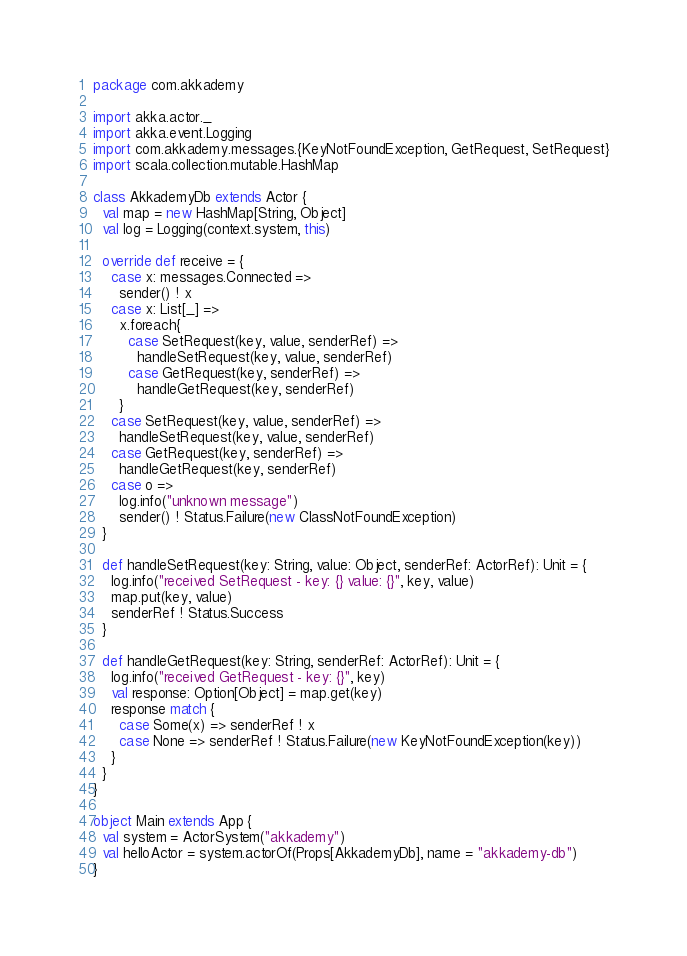<code> <loc_0><loc_0><loc_500><loc_500><_Scala_>package com.akkademy

import akka.actor._
import akka.event.Logging
import com.akkademy.messages.{KeyNotFoundException, GetRequest, SetRequest}
import scala.collection.mutable.HashMap

class AkkademyDb extends Actor {
  val map = new HashMap[String, Object]
  val log = Logging(context.system, this)

  override def receive = {
    case x: messages.Connected =>
      sender() ! x
    case x: List[_] =>
      x.foreach{
        case SetRequest(key, value, senderRef) =>
          handleSetRequest(key, value, senderRef)
        case GetRequest(key, senderRef) =>
          handleGetRequest(key, senderRef)
      }
    case SetRequest(key, value, senderRef) =>
      handleSetRequest(key, value, senderRef)
    case GetRequest(key, senderRef) =>
      handleGetRequest(key, senderRef)
    case o =>
      log.info("unknown message")
      sender() ! Status.Failure(new ClassNotFoundException)
  }

  def handleSetRequest(key: String, value: Object, senderRef: ActorRef): Unit = {
    log.info("received SetRequest - key: {} value: {}", key, value)
    map.put(key, value)
    senderRef ! Status.Success
  }

  def handleGetRequest(key: String, senderRef: ActorRef): Unit = {
    log.info("received GetRequest - key: {}", key)
    val response: Option[Object] = map.get(key)
    response match {
      case Some(x) => senderRef ! x
      case None => senderRef ! Status.Failure(new KeyNotFoundException(key))
    }
  }
}

object Main extends App {
  val system = ActorSystem("akkademy")
  val helloActor = system.actorOf(Props[AkkademyDb], name = "akkademy-db")
}
</code> 